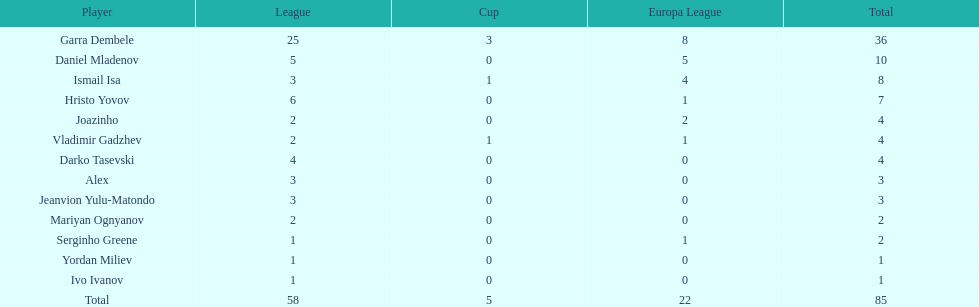What is the combined total of the cup and the europa league? 27. 